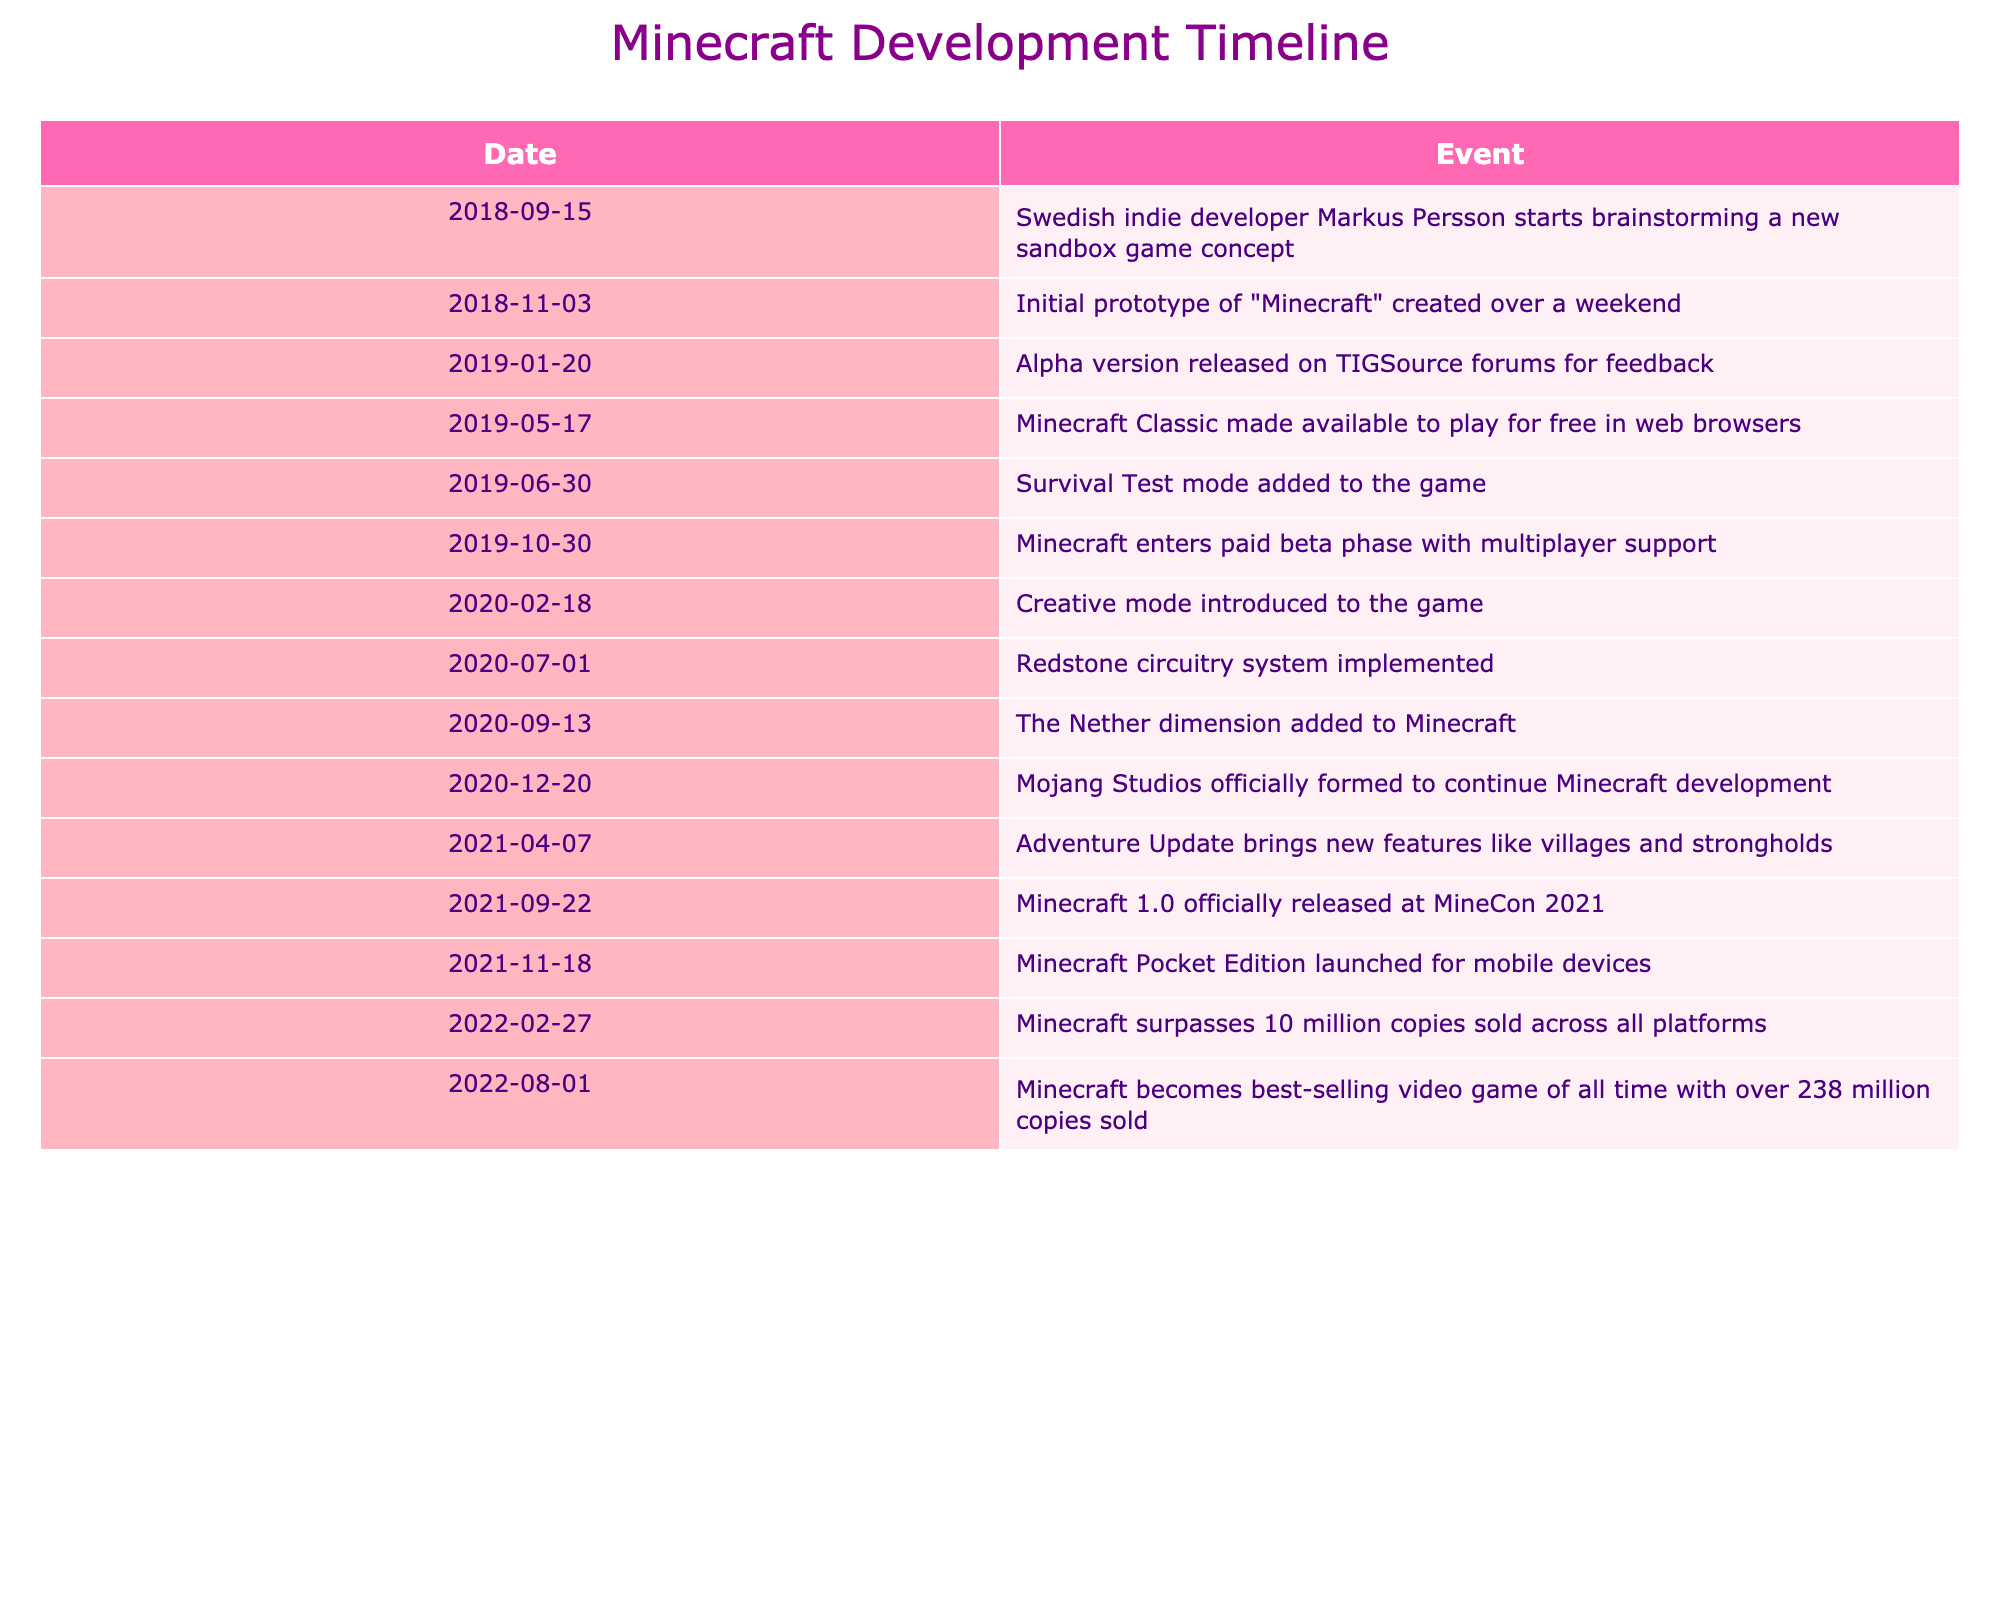What date did the initial prototype of Minecraft get created? The table states that the initial prototype of "Minecraft" was created on November 3, 2018. This is clearly indicated in the Event column under the corresponding date.
Answer: November 3, 2018 When was the Survival Test mode added to the game? According to the table, the Survival Test mode was added on June 30, 2019, as noted in the respective row.
Answer: June 30, 2019 Did Minecraft Classic made available to play before the paid beta phase? The table shows that Minecraft Classic was made available on May 17, 2019, while the paid beta phase started on October 30, 2019. Since May is before October, the answer is yes.
Answer: Yes What is the difference in months between the release of the Creative mode and the Adventure Update? Creative mode was introduced on February 18, 2020, and the Adventure Update was released on April 7, 2021. The difference between these two dates is a bit over 13 months when calculated (from February 2020 to March 2021 is 13 months, and then add 7 days).
Answer: 13 months How many events occurred in the year 2021? By examining the table, we can see there are three distinct events recorded in 2021: the official release, the launch of the Pocket Edition, and the Adventure Update. Counting those gives a total of three events.
Answer: 3 What was the last event listed before Mojang Studios was formed? The table indicates that the last event before Mojang Studios was officially formed on December 20, 2020, was the addition of the Nether dimension on September 13, 2020. This is the event that immediately precedes the formation of Mojang Studios.
Answer: Addition of the Nether dimension What was the number of games sold when Minecraft surpassed 10 million copies? According to the table, Minecraft surpassed 10 million copies sold on February 27, 2022. This indicates that the milestone of selling 10 million copies was reached at this time, so the answer is simply the figure mentioned in that entry.
Answer: 10 million What is the timeline from the initial prototype creation to the official release in days? The initial prototype was created on November 3, 2018, and the official release occurred on September 22, 2021. The number of days can be calculated by subtracting the dates: from November 3, 2018, to September 22, 2021, is 1,067 days.
Answer: 1,067 days 